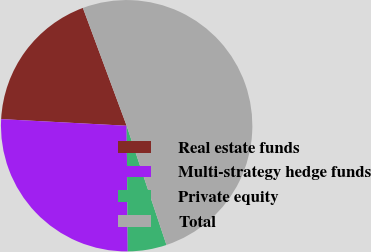Convert chart to OTSL. <chart><loc_0><loc_0><loc_500><loc_500><pie_chart><fcel>Real estate funds<fcel>Multi-strategy hedge funds<fcel>Private equity<fcel>Total<nl><fcel>18.5%<fcel>25.98%<fcel>4.99%<fcel>50.53%<nl></chart> 